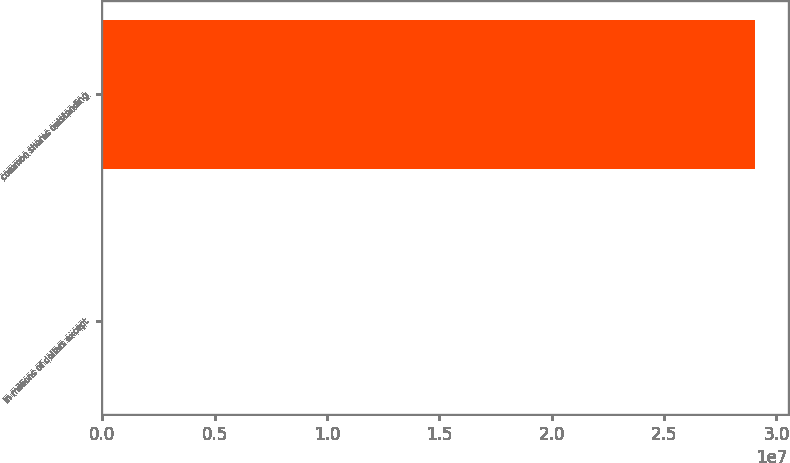<chart> <loc_0><loc_0><loc_500><loc_500><bar_chart><fcel>In millions of dollars except<fcel>common shares outstanding<nl><fcel>2010<fcel>2.90584e+07<nl></chart> 